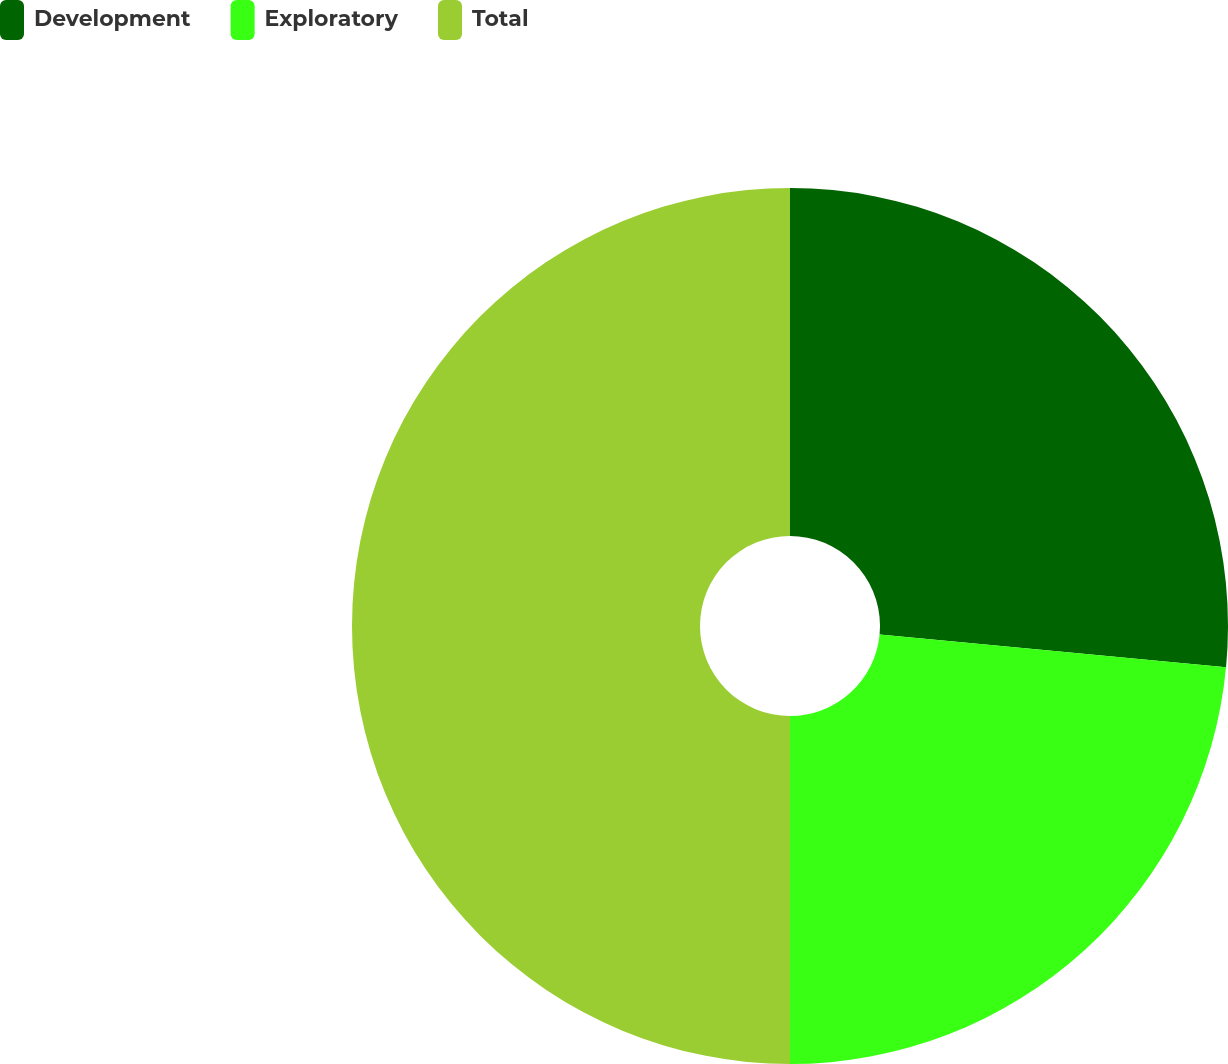Convert chart to OTSL. <chart><loc_0><loc_0><loc_500><loc_500><pie_chart><fcel>Development<fcel>Exploratory<fcel>Total<nl><fcel>26.5%<fcel>23.5%<fcel>50.0%<nl></chart> 